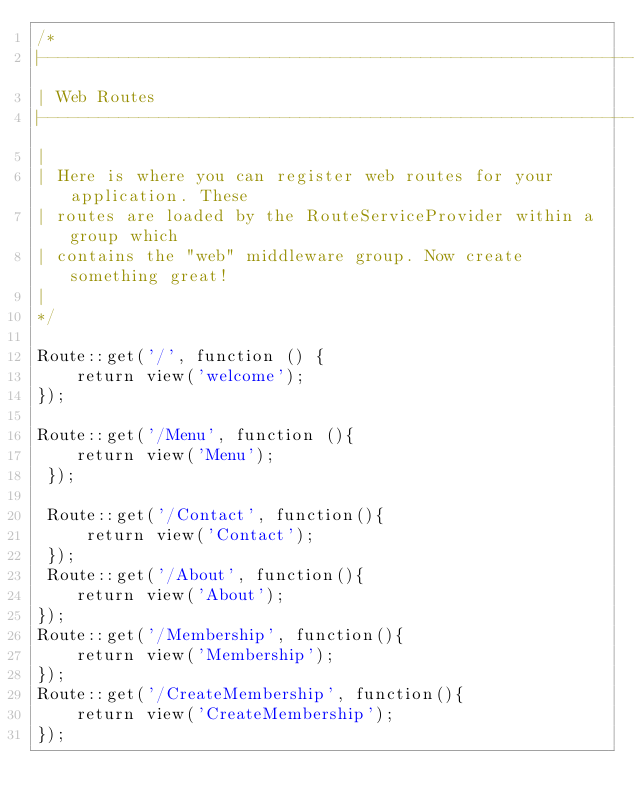<code> <loc_0><loc_0><loc_500><loc_500><_PHP_>/*
|--------------------------------------------------------------------------
| Web Routes
|--------------------------------------------------------------------------
|
| Here is where you can register web routes for your application. These
| routes are loaded by the RouteServiceProvider within a group which
| contains the "web" middleware group. Now create something great!
|
*/

Route::get('/', function () {
    return view('welcome');
});

Route::get('/Menu', function (){
    return view('Menu');
 });

 Route::get('/Contact', function(){
     return view('Contact');
 });
 Route::get('/About', function(){
    return view('About');
});
Route::get('/Membership', function(){
    return view('Membership');
});
Route::get('/CreateMembership', function(){
    return view('CreateMembership');
});


</code> 